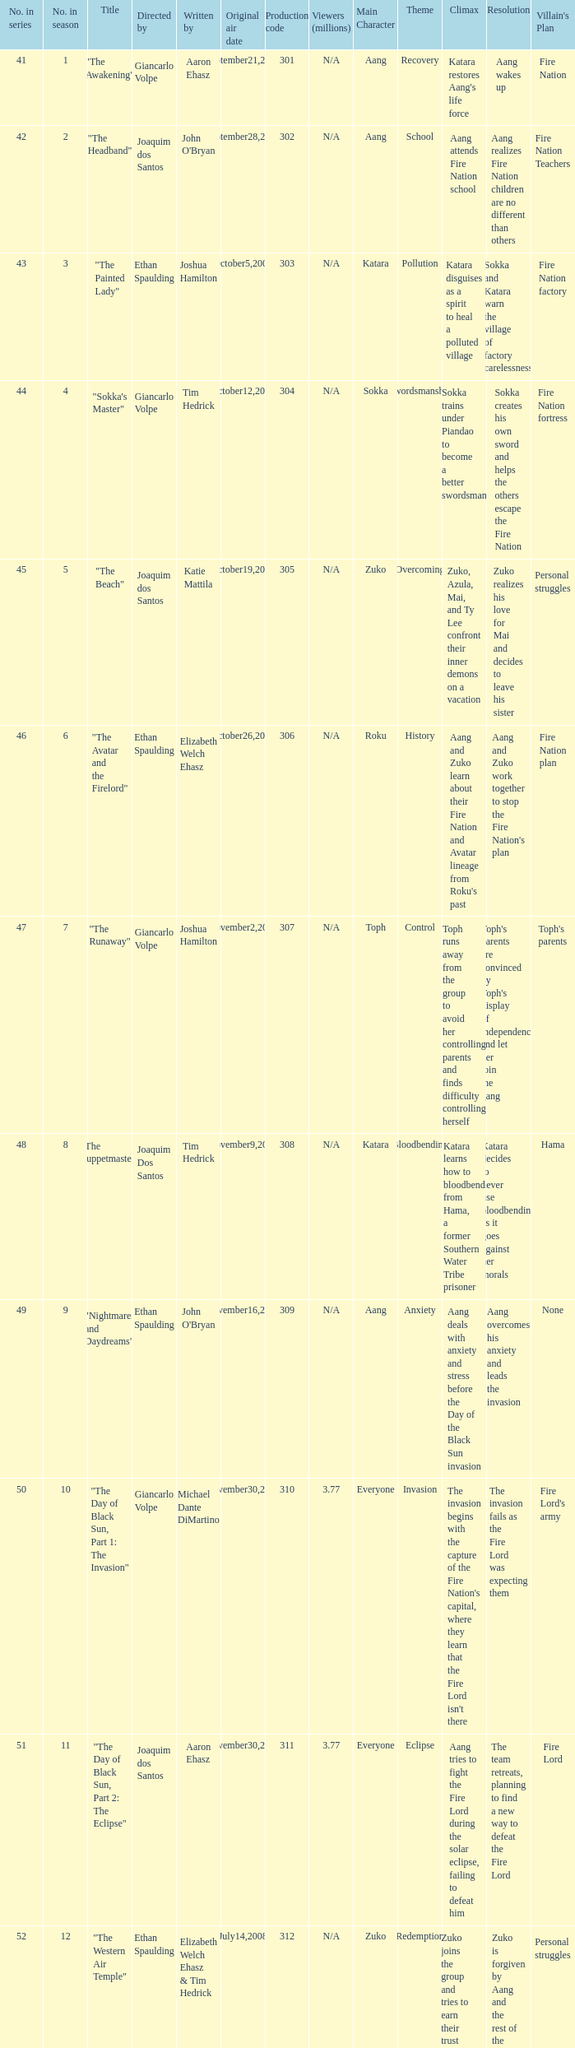How many viewers in millions for episode "sokka's master"? N/A. 